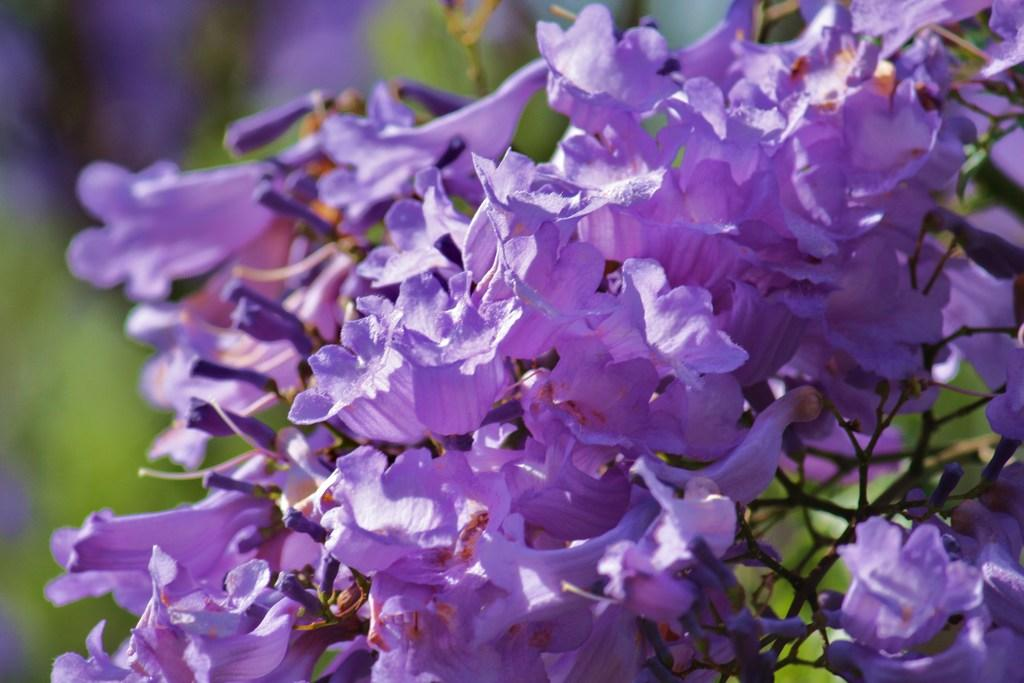What is the main subject of the image? The main subject of the image is a group of flowers. Can you describe the flowers in more detail? The flowers are on a stem of a plant. What type of zebra can be seen interacting with the flowers in the image? There is no zebra present in the image; it only features a group of flowers on a stem of a plant. 